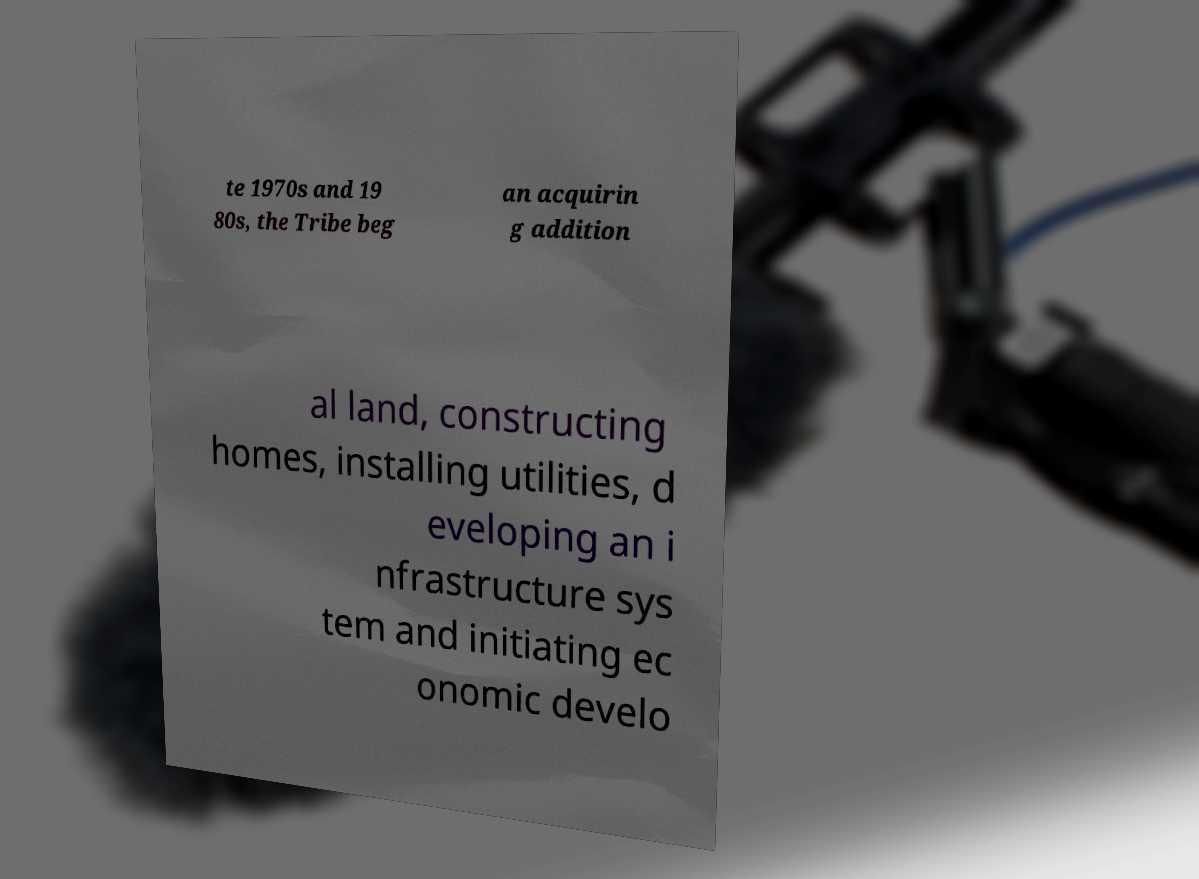Can you read and provide the text displayed in the image?This photo seems to have some interesting text. Can you extract and type it out for me? te 1970s and 19 80s, the Tribe beg an acquirin g addition al land, constructing homes, installing utilities, d eveloping an i nfrastructure sys tem and initiating ec onomic develo 